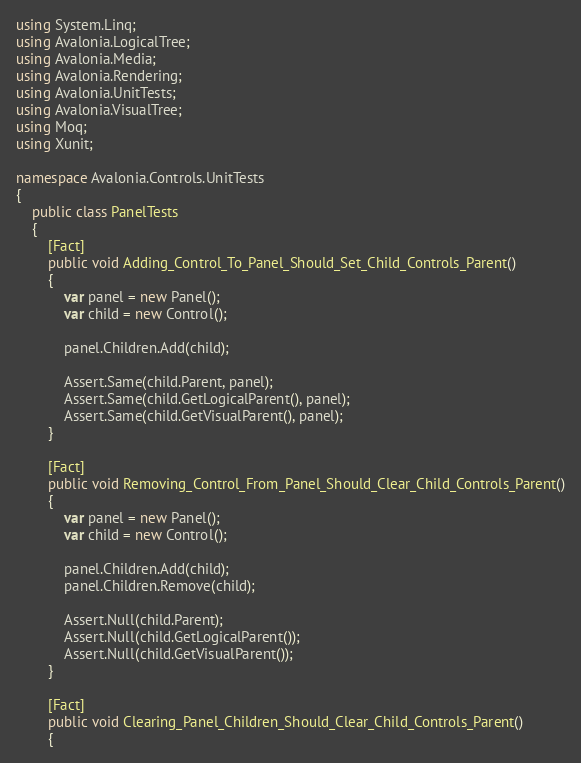Convert code to text. <code><loc_0><loc_0><loc_500><loc_500><_C#_>using System.Linq;
using Avalonia.LogicalTree;
using Avalonia.Media;
using Avalonia.Rendering;
using Avalonia.UnitTests;
using Avalonia.VisualTree;
using Moq;
using Xunit;

namespace Avalonia.Controls.UnitTests
{
    public class PanelTests
    {
        [Fact]
        public void Adding_Control_To_Panel_Should_Set_Child_Controls_Parent()
        {
            var panel = new Panel();
            var child = new Control();

            panel.Children.Add(child);

            Assert.Same(child.Parent, panel);
            Assert.Same(child.GetLogicalParent(), panel);
            Assert.Same(child.GetVisualParent(), panel);
        }

        [Fact]
        public void Removing_Control_From_Panel_Should_Clear_Child_Controls_Parent()
        {
            var panel = new Panel();
            var child = new Control();

            panel.Children.Add(child);
            panel.Children.Remove(child);

            Assert.Null(child.Parent);
            Assert.Null(child.GetLogicalParent());
            Assert.Null(child.GetVisualParent());
        }

        [Fact]
        public void Clearing_Panel_Children_Should_Clear_Child_Controls_Parent()
        {</code> 